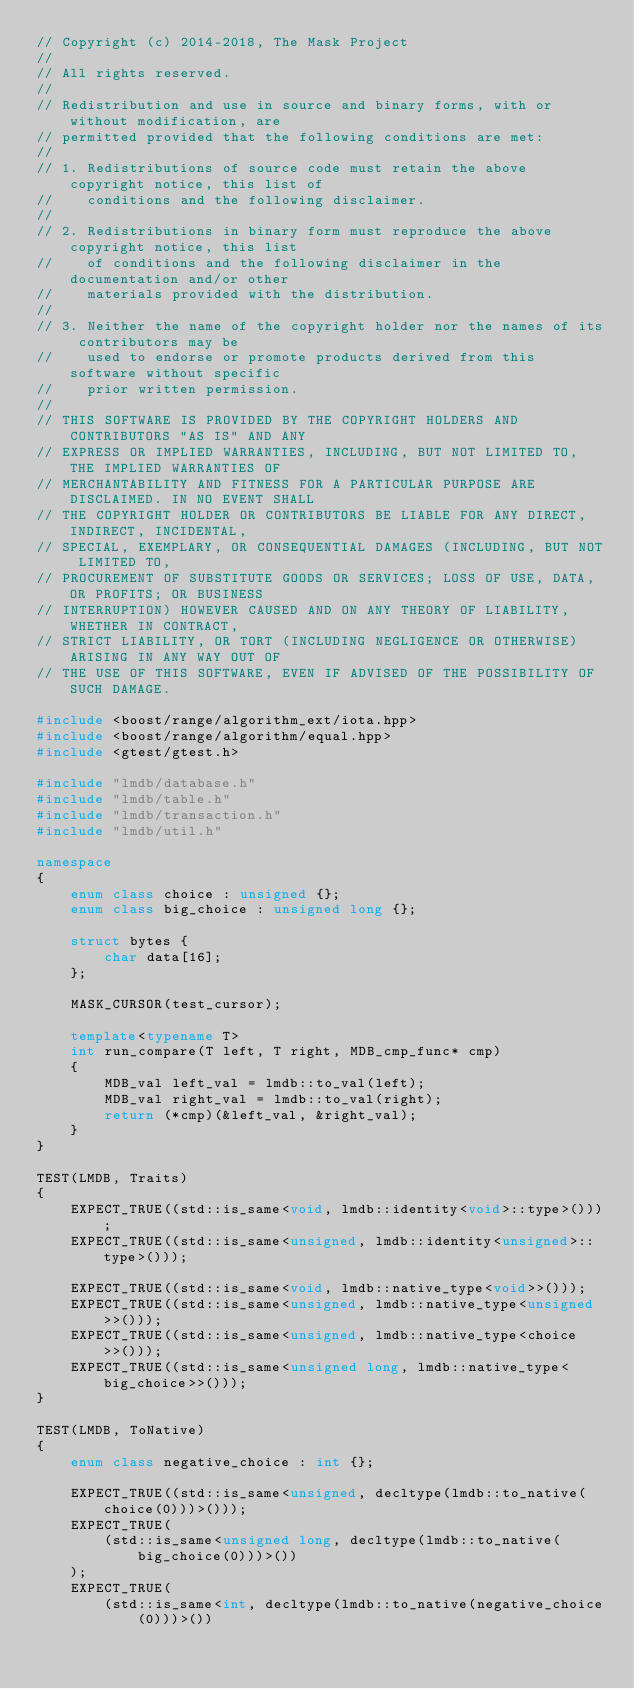<code> <loc_0><loc_0><loc_500><loc_500><_C++_>// Copyright (c) 2014-2018, The Mask Project
// 
// All rights reserved.
// 
// Redistribution and use in source and binary forms, with or without modification, are
// permitted provided that the following conditions are met:
// 
// 1. Redistributions of source code must retain the above copyright notice, this list of
//    conditions and the following disclaimer.
// 
// 2. Redistributions in binary form must reproduce the above copyright notice, this list
//    of conditions and the following disclaimer in the documentation and/or other
//    materials provided with the distribution.
// 
// 3. Neither the name of the copyright holder nor the names of its contributors may be
//    used to endorse or promote products derived from this software without specific
//    prior written permission.
// 
// THIS SOFTWARE IS PROVIDED BY THE COPYRIGHT HOLDERS AND CONTRIBUTORS "AS IS" AND ANY
// EXPRESS OR IMPLIED WARRANTIES, INCLUDING, BUT NOT LIMITED TO, THE IMPLIED WARRANTIES OF
// MERCHANTABILITY AND FITNESS FOR A PARTICULAR PURPOSE ARE DISCLAIMED. IN NO EVENT SHALL
// THE COPYRIGHT HOLDER OR CONTRIBUTORS BE LIABLE FOR ANY DIRECT, INDIRECT, INCIDENTAL,
// SPECIAL, EXEMPLARY, OR CONSEQUENTIAL DAMAGES (INCLUDING, BUT NOT LIMITED TO,
// PROCUREMENT OF SUBSTITUTE GOODS OR SERVICES; LOSS OF USE, DATA, OR PROFITS; OR BUSINESS
// INTERRUPTION) HOWEVER CAUSED AND ON ANY THEORY OF LIABILITY, WHETHER IN CONTRACT,
// STRICT LIABILITY, OR TORT (INCLUDING NEGLIGENCE OR OTHERWISE) ARISING IN ANY WAY OUT OF
// THE USE OF THIS SOFTWARE, EVEN IF ADVISED OF THE POSSIBILITY OF SUCH DAMAGE.

#include <boost/range/algorithm_ext/iota.hpp>
#include <boost/range/algorithm/equal.hpp>
#include <gtest/gtest.h>

#include "lmdb/database.h"
#include "lmdb/table.h"
#include "lmdb/transaction.h"
#include "lmdb/util.h"

namespace
{
    enum class choice : unsigned {};
    enum class big_choice : unsigned long {};

    struct bytes {
        char data[16];
    };

    MASK_CURSOR(test_cursor);

    template<typename T>
    int run_compare(T left, T right, MDB_cmp_func* cmp)
    {
        MDB_val left_val = lmdb::to_val(left);
        MDB_val right_val = lmdb::to_val(right);
        return (*cmp)(&left_val, &right_val);
    }
}

TEST(LMDB, Traits)
{
    EXPECT_TRUE((std::is_same<void, lmdb::identity<void>::type>()));
    EXPECT_TRUE((std::is_same<unsigned, lmdb::identity<unsigned>::type>()));

    EXPECT_TRUE((std::is_same<void, lmdb::native_type<void>>()));
    EXPECT_TRUE((std::is_same<unsigned, lmdb::native_type<unsigned>>()));
    EXPECT_TRUE((std::is_same<unsigned, lmdb::native_type<choice>>()));
    EXPECT_TRUE((std::is_same<unsigned long, lmdb::native_type<big_choice>>()));
}

TEST(LMDB, ToNative)
{
    enum class negative_choice : int {};

    EXPECT_TRUE((std::is_same<unsigned, decltype(lmdb::to_native(choice(0)))>()));
    EXPECT_TRUE(
        (std::is_same<unsigned long, decltype(lmdb::to_native(big_choice(0)))>())
    );
    EXPECT_TRUE(
        (std::is_same<int, decltype(lmdb::to_native(negative_choice(0)))>())</code> 